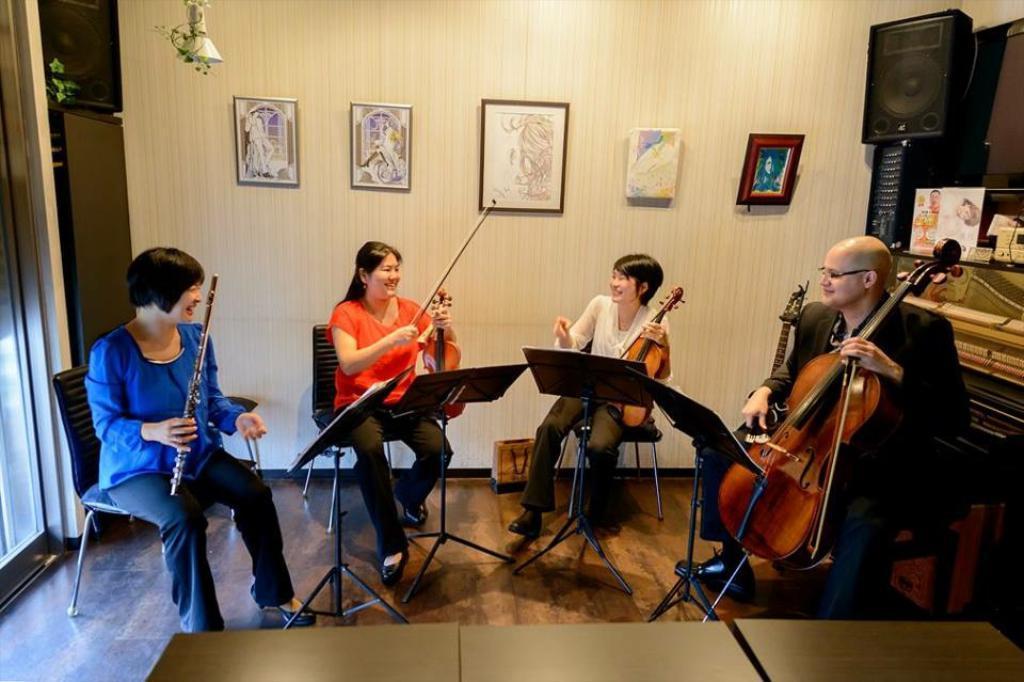How would you summarize this image in a sentence or two? In the image we can see there are people who are sitting on chair and playing musical instrument. 